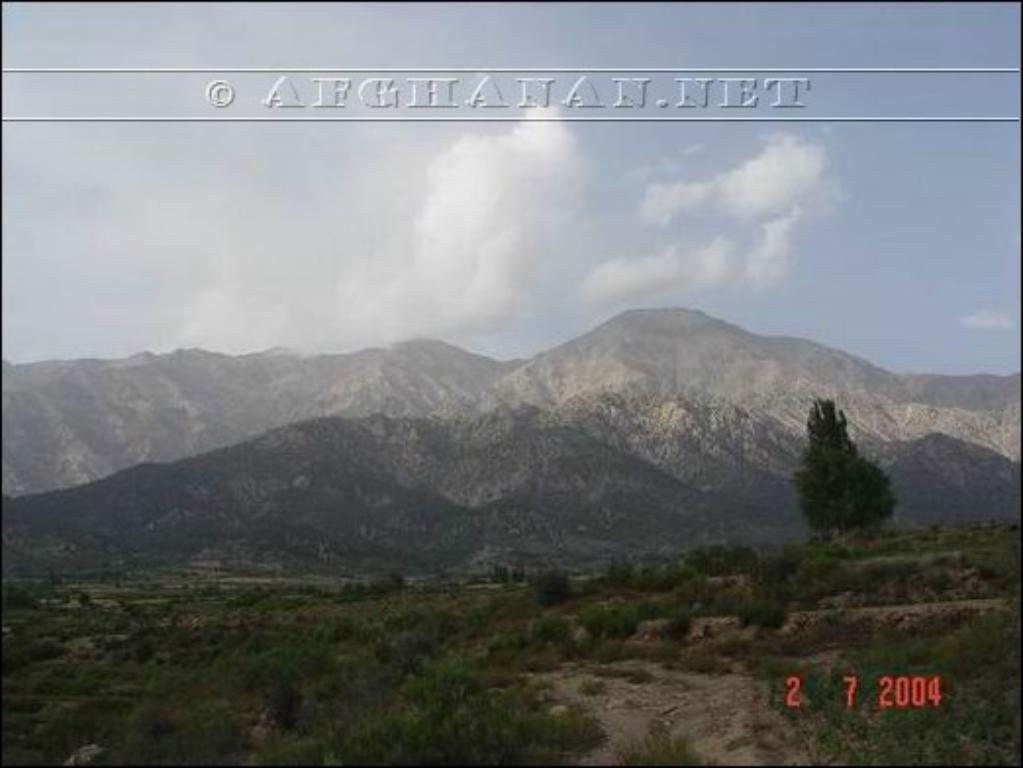What type of natural landscape is depicted in the image? The image features mountains. What is the weather like in the image? There is snow and clouds in the image, indicating a cold and possibly snowy or overcast day. What type of vegetation can be seen in the image? There are grass, plants, and trees in the image. What is visible in the sky in the image? The sky is visible in the image, with clouds present. Are there any watermarks in the image? Yes, there are watermarks in the image. What type of food is being served in the vessel in the image? There is no vessel or food present in the image; it features a mountain landscape with snow, grass, plants, trees, and clouds. 